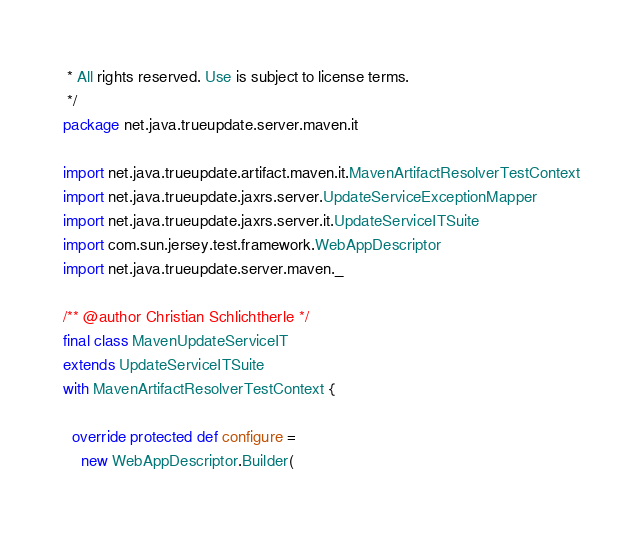<code> <loc_0><loc_0><loc_500><loc_500><_Scala_> * All rights reserved. Use is subject to license terms.
 */
package net.java.trueupdate.server.maven.it

import net.java.trueupdate.artifact.maven.it.MavenArtifactResolverTestContext
import net.java.trueupdate.jaxrs.server.UpdateServiceExceptionMapper
import net.java.trueupdate.jaxrs.server.it.UpdateServiceITSuite
import com.sun.jersey.test.framework.WebAppDescriptor
import net.java.trueupdate.server.maven._

/** @author Christian Schlichtherle */
final class MavenUpdateServiceIT
extends UpdateServiceITSuite
with MavenArtifactResolverTestContext {

  override protected def configure =
    new WebAppDescriptor.Builder(</code> 